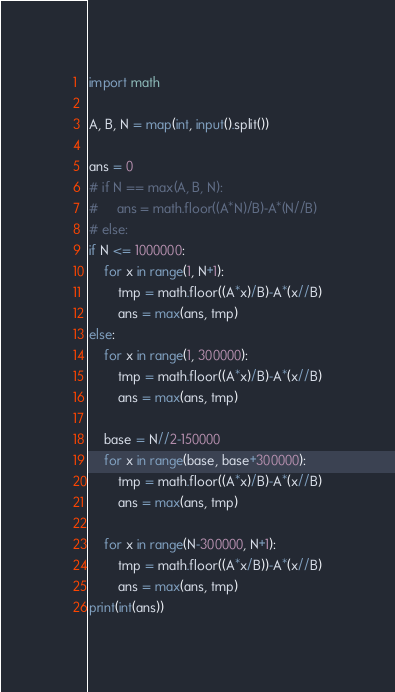Convert code to text. <code><loc_0><loc_0><loc_500><loc_500><_Python_>import math

A, B, N = map(int, input().split())

ans = 0
# if N == max(A, B, N):
#     ans = math.floor((A*N)/B)-A*(N//B)
# else:
if N <= 1000000:
    for x in range(1, N+1):
        tmp = math.floor((A*x)/B)-A*(x//B)
        ans = max(ans, tmp)
else:
    for x in range(1, 300000):
        tmp = math.floor((A*x)/B)-A*(x//B)
        ans = max(ans, tmp)

    base = N//2-150000
    for x in range(base, base+300000):
        tmp = math.floor((A*x)/B)-A*(x//B)
        ans = max(ans, tmp)

    for x in range(N-300000, N+1):
        tmp = math.floor((A*x/B))-A*(x//B)
        ans = max(ans, tmp)
print(int(ans))
</code> 